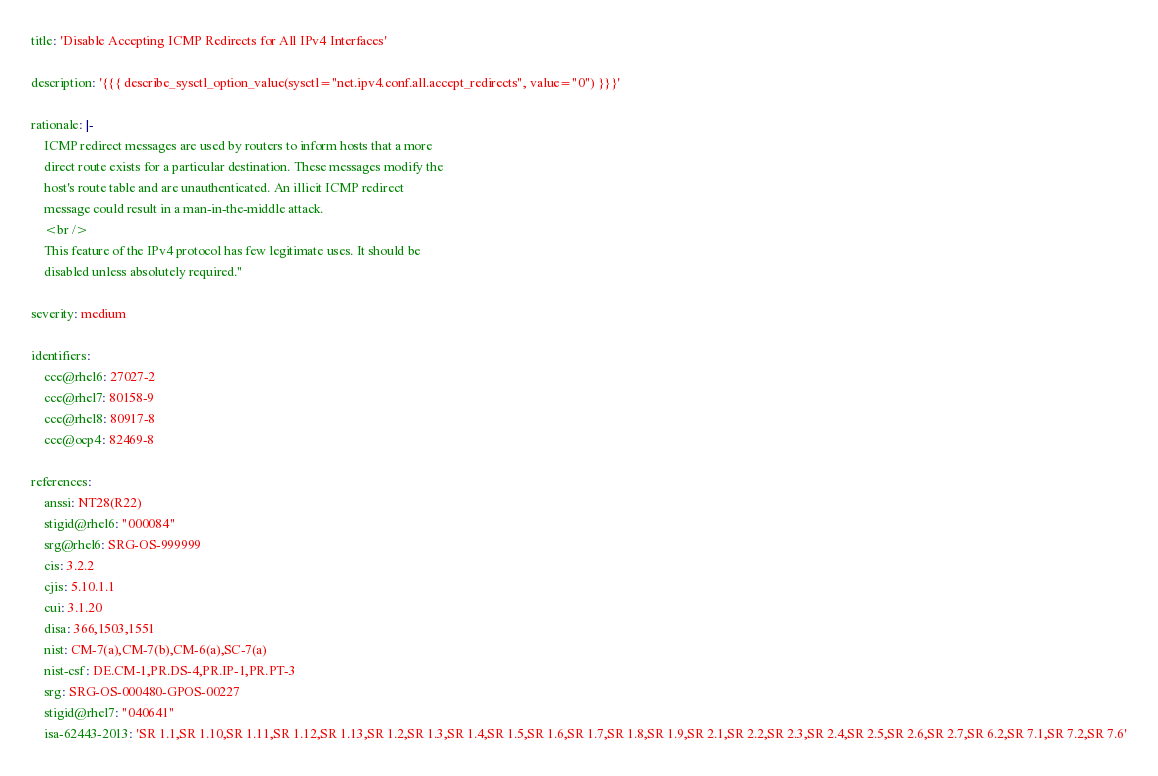Convert code to text. <code><loc_0><loc_0><loc_500><loc_500><_YAML_>
title: 'Disable Accepting ICMP Redirects for All IPv4 Interfaces'

description: '{{{ describe_sysctl_option_value(sysctl="net.ipv4.conf.all.accept_redirects", value="0") }}}'

rationale: |-
    ICMP redirect messages are used by routers to inform hosts that a more
    direct route exists for a particular destination. These messages modify the
    host's route table and are unauthenticated. An illicit ICMP redirect
    message could result in a man-in-the-middle attack.
    <br />
    This feature of the IPv4 protocol has few legitimate uses. It should be
    disabled unless absolutely required."

severity: medium

identifiers:
    cce@rhel6: 27027-2
    cce@rhel7: 80158-9
    cce@rhel8: 80917-8
    cce@ocp4: 82469-8

references:
    anssi: NT28(R22)
    stigid@rhel6: "000084"
    srg@rhel6: SRG-OS-999999
    cis: 3.2.2
    cjis: 5.10.1.1
    cui: 3.1.20
    disa: 366,1503,1551
    nist: CM-7(a),CM-7(b),CM-6(a),SC-7(a)
    nist-csf: DE.CM-1,PR.DS-4,PR.IP-1,PR.PT-3
    srg: SRG-OS-000480-GPOS-00227
    stigid@rhel7: "040641"
    isa-62443-2013: 'SR 1.1,SR 1.10,SR 1.11,SR 1.12,SR 1.13,SR 1.2,SR 1.3,SR 1.4,SR 1.5,SR 1.6,SR 1.7,SR 1.8,SR 1.9,SR 2.1,SR 2.2,SR 2.3,SR 2.4,SR 2.5,SR 2.6,SR 2.7,SR 6.2,SR 7.1,SR 7.2,SR 7.6'</code> 